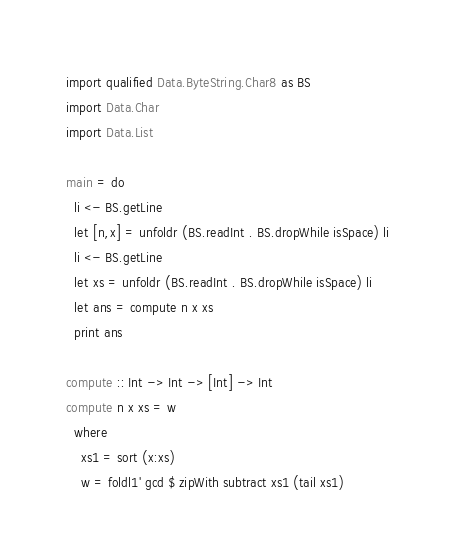<code> <loc_0><loc_0><loc_500><loc_500><_Haskell_>import qualified Data.ByteString.Char8 as BS
import Data.Char
import Data.List

main = do
  li <- BS.getLine
  let [n,x] = unfoldr (BS.readInt . BS.dropWhile isSpace) li
  li <- BS.getLine
  let xs = unfoldr (BS.readInt . BS.dropWhile isSpace) li
  let ans = compute n x xs
  print ans

compute :: Int -> Int -> [Int] -> Int
compute n x xs = w
  where
    xs1 = sort (x:xs)
    w = foldl1' gcd $ zipWith subtract xs1 (tail xs1)
</code> 